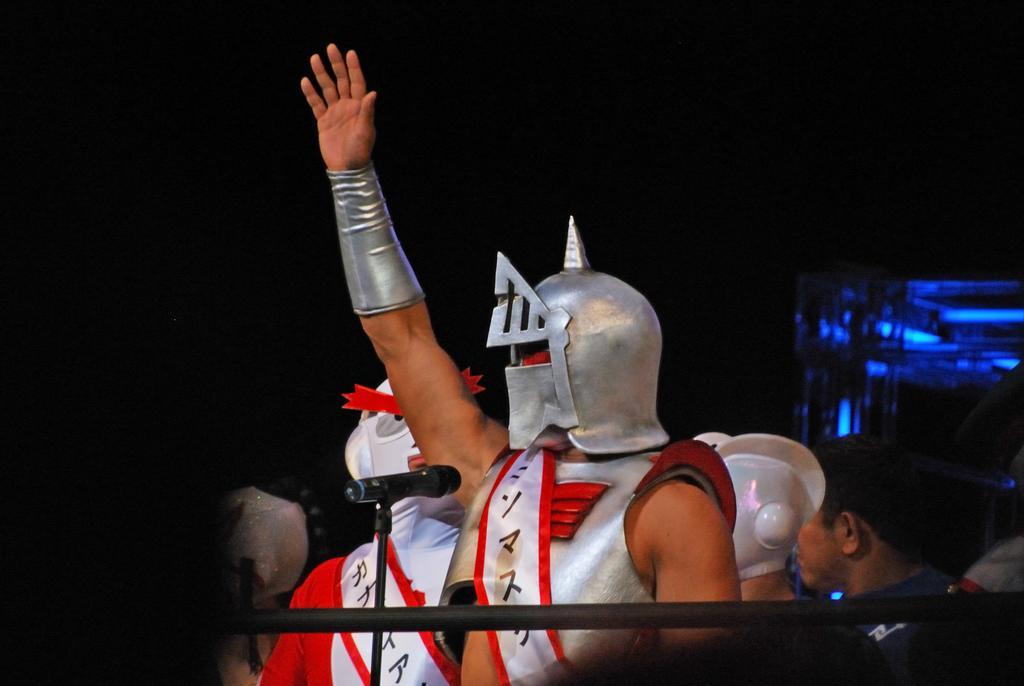Could you give a brief overview of what you see in this image? In this image I can see group of people standing. In front the person is wearing silver color dress and I can see the dark background. 